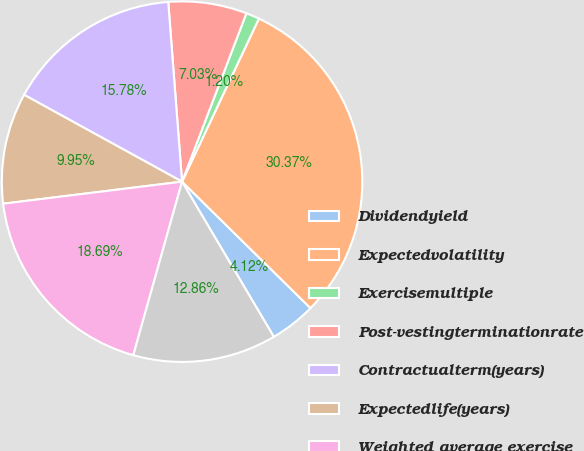<chart> <loc_0><loc_0><loc_500><loc_500><pie_chart><fcel>Dividendyield<fcel>Expectedvolatility<fcel>Exercisemultiple<fcel>Post-vestingterminationrate<fcel>Contractualterm(years)<fcel>Expectedlife(years)<fcel>Weighted average exercise<fcel>Weighted average fair value of<nl><fcel>4.12%<fcel>30.37%<fcel>1.2%<fcel>7.03%<fcel>15.78%<fcel>9.95%<fcel>18.69%<fcel>12.86%<nl></chart> 